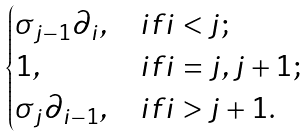Convert formula to latex. <formula><loc_0><loc_0><loc_500><loc_500>\begin{cases} \sigma _ { j - 1 } \partial _ { i } , & i f i < j ; \\ 1 , & i f i = j , j + 1 ; \\ \sigma _ { j } \partial _ { i - 1 } , & i f i > j + 1 . \end{cases}</formula> 